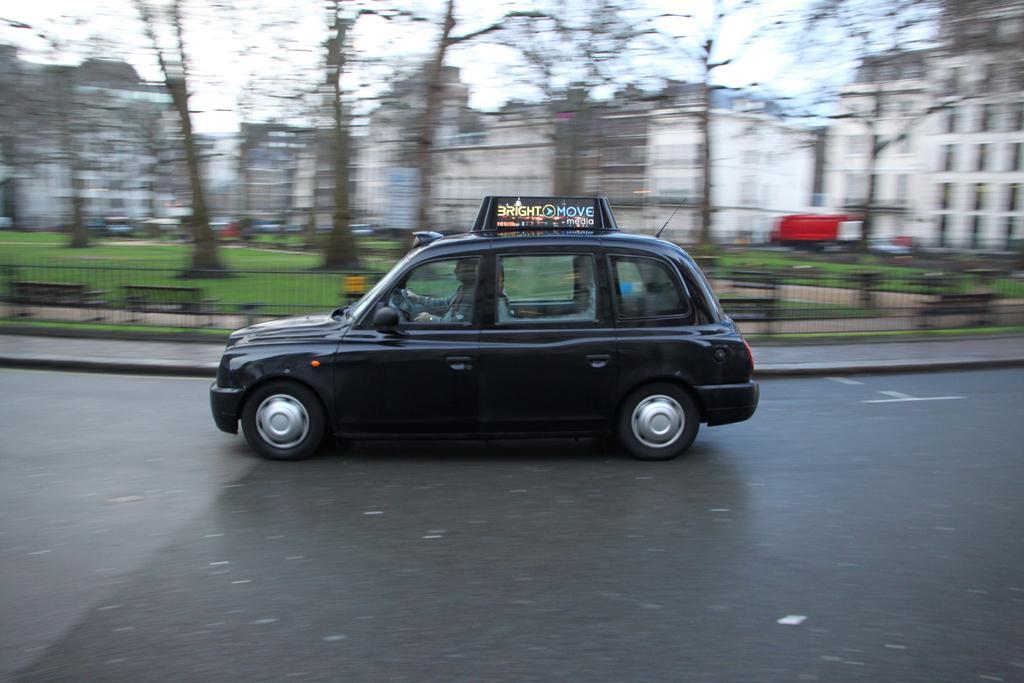Describe this image in one or two sentences. In this image we can see a black color car on the road. In the background of the image there are buildings, trees, fencing. 